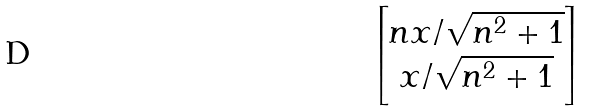Convert formula to latex. <formula><loc_0><loc_0><loc_500><loc_500>\begin{bmatrix} n x / \sqrt { n ^ { 2 } + 1 } \\ x / \sqrt { n ^ { 2 } + 1 } \end{bmatrix}</formula> 